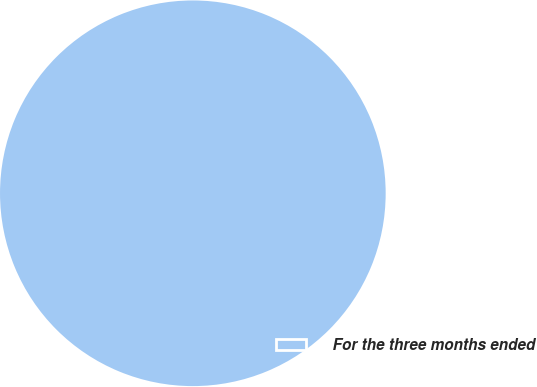Convert chart to OTSL. <chart><loc_0><loc_0><loc_500><loc_500><pie_chart><fcel>For the three months ended<nl><fcel>100.0%<nl></chart> 